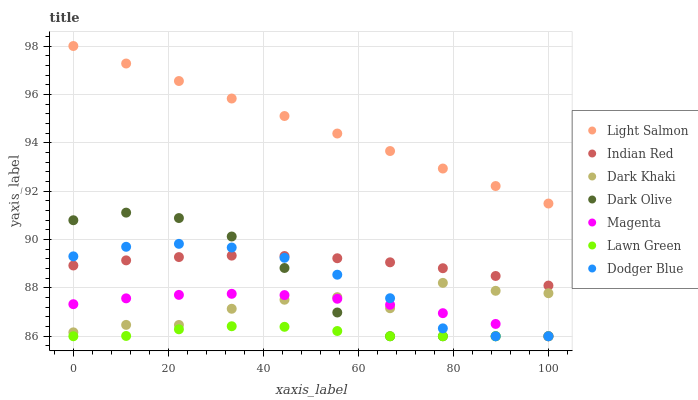Does Lawn Green have the minimum area under the curve?
Answer yes or no. Yes. Does Light Salmon have the maximum area under the curve?
Answer yes or no. Yes. Does Dark Olive have the minimum area under the curve?
Answer yes or no. No. Does Dark Olive have the maximum area under the curve?
Answer yes or no. No. Is Light Salmon the smoothest?
Answer yes or no. Yes. Is Dark Khaki the roughest?
Answer yes or no. Yes. Is Dark Olive the smoothest?
Answer yes or no. No. Is Dark Olive the roughest?
Answer yes or no. No. Does Lawn Green have the lowest value?
Answer yes or no. Yes. Does Light Salmon have the lowest value?
Answer yes or no. No. Does Light Salmon have the highest value?
Answer yes or no. Yes. Does Dark Olive have the highest value?
Answer yes or no. No. Is Dark Olive less than Light Salmon?
Answer yes or no. Yes. Is Light Salmon greater than Dark Khaki?
Answer yes or no. Yes. Does Dark Olive intersect Indian Red?
Answer yes or no. Yes. Is Dark Olive less than Indian Red?
Answer yes or no. No. Is Dark Olive greater than Indian Red?
Answer yes or no. No. Does Dark Olive intersect Light Salmon?
Answer yes or no. No. 